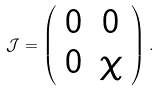<formula> <loc_0><loc_0><loc_500><loc_500>\mathcal { J } = \left ( \begin{array} { c c } 0 & 0 \\ 0 & \chi \end{array} \right ) .</formula> 